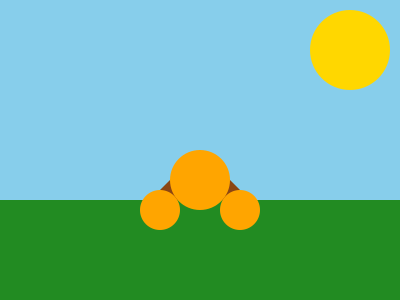When capturing a family portrait of a father with his triplets in an outdoor setting during golden hour, which white balance setting would be most appropriate to accurately render the warm tones of the scene? To determine the most appropriate white balance setting for a family portrait during golden hour, we need to consider the following factors:

1. Golden hour lighting: This occurs shortly after sunrise or before sunset, producing warm, soft light with a color temperature around 2000-3000K.

2. Color temperature scale:
   - Tungsten: ~3200K
   - Fluorescent: ~4000K
   - Daylight: ~5500K
   - Cloudy: ~6500K
   - Shade: ~7500K

3. Camera white balance options:
   - Auto White Balance (AWB)
   - Daylight
   - Cloudy
   - Shade
   - Tungsten
   - Fluorescent
   - Custom

4. Golden hour characteristics:
   - Warm, orange-yellow tones
   - Soft, diffused light
   - Lower color temperature than midday sunlight

5. Portrait considerations:
   - Accurate skin tones
   - Warm, inviting atmosphere

Given these factors, the most appropriate white balance setting would be:

- Daylight or Sunny: This setting is calibrated for a color temperature of around 5500K, which is slightly cooler than golden hour light.
- Using the Daylight setting will preserve the warm tones of golden hour, allowing the camera to capture the natural warmth of the scene without over-correcting.
- This setting will also help maintain accurate skin tones while still conveying the inviting atmosphere of golden hour light.

Alternative options:
- Custom white balance: For precise control, you could use a gray card to set a custom white balance.
- Cloudy: This setting (around 6500K) might be too cool and could neutralize the warm golden hour tones.
- AWB: While convenient, it may not consistently capture the warmth of golden hour lighting.
Answer: Daylight white balance setting 